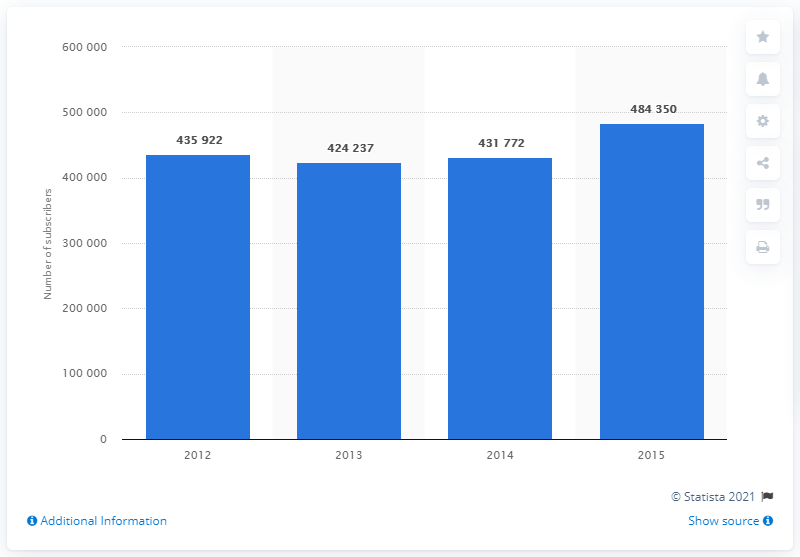Indicate a few pertinent items in this graphic. There were 431,772 mobile subscribers in Albania in 2014. 